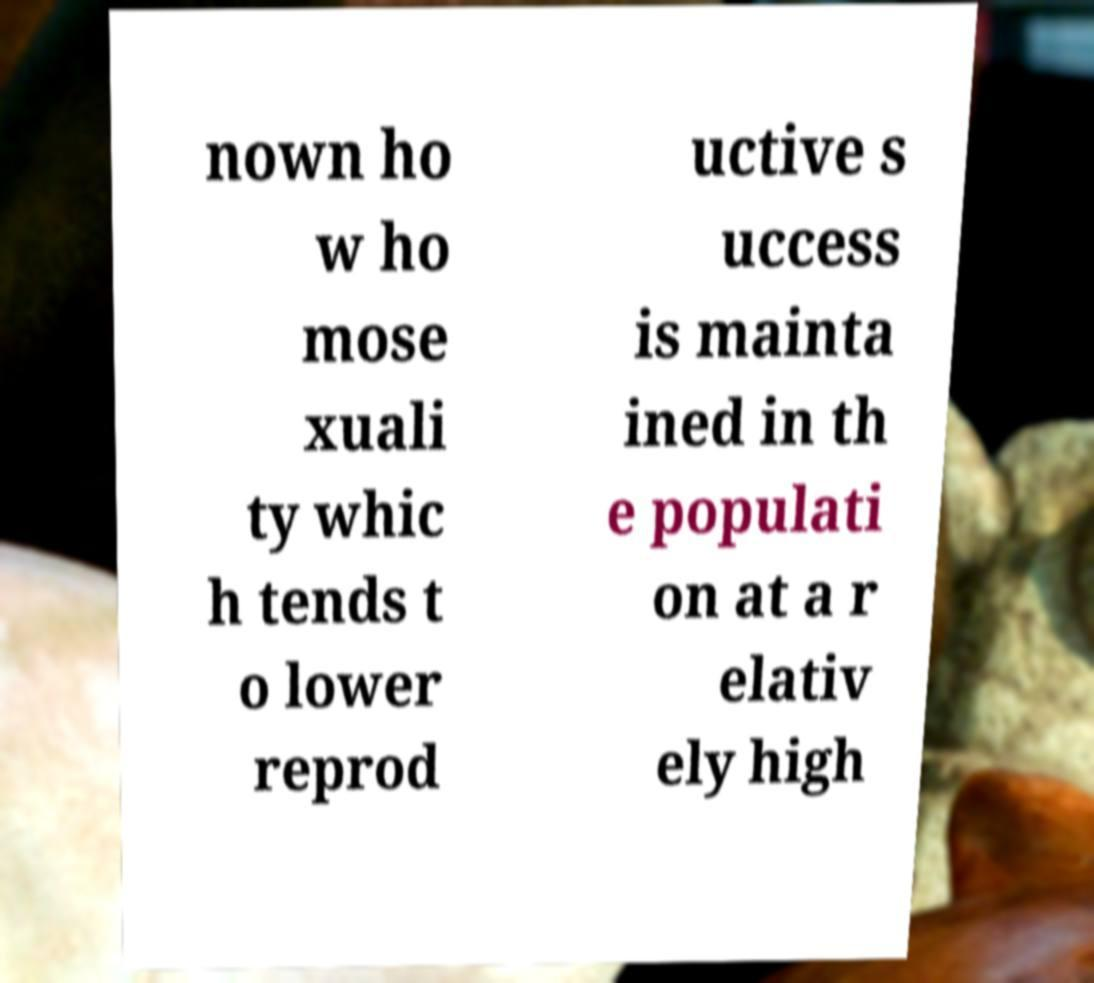Please read and relay the text visible in this image. What does it say? nown ho w ho mose xuali ty whic h tends t o lower reprod uctive s uccess is mainta ined in th e populati on at a r elativ ely high 